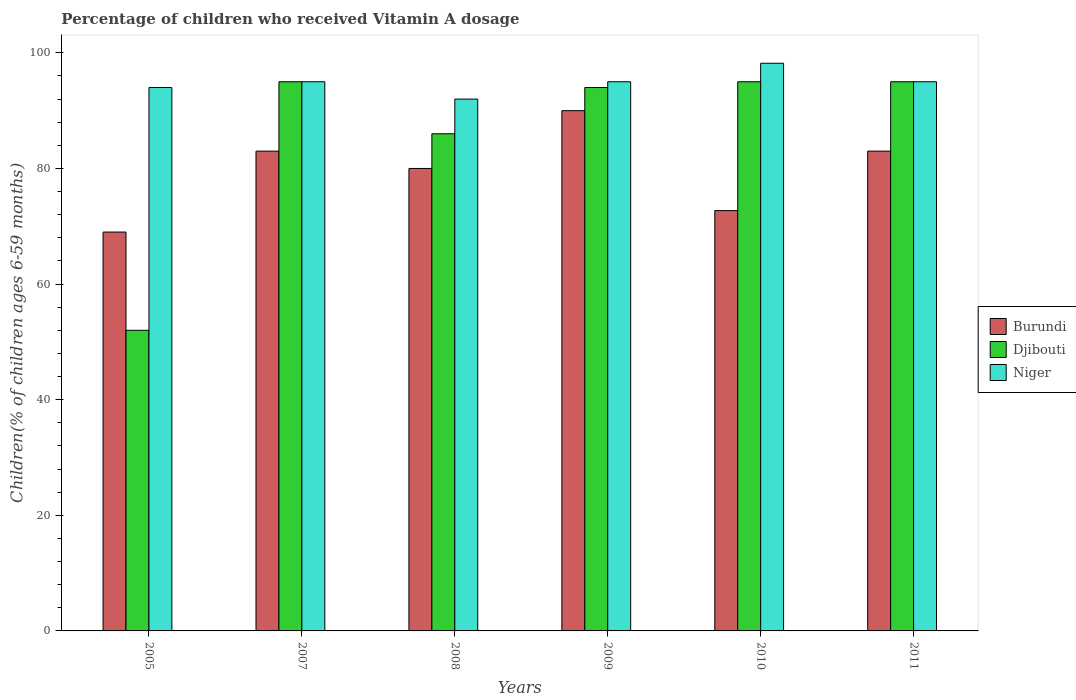How many groups of bars are there?
Keep it short and to the point. 6. How many bars are there on the 1st tick from the right?
Ensure brevity in your answer.  3. What is the label of the 3rd group of bars from the left?
Your answer should be very brief. 2008. In how many cases, is the number of bars for a given year not equal to the number of legend labels?
Keep it short and to the point. 0. What is the percentage of children who received Vitamin A dosage in Niger in 2008?
Offer a terse response. 92. Across all years, what is the maximum percentage of children who received Vitamin A dosage in Djibouti?
Your response must be concise. 95. Across all years, what is the minimum percentage of children who received Vitamin A dosage in Burundi?
Provide a short and direct response. 69. In which year was the percentage of children who received Vitamin A dosage in Niger maximum?
Your answer should be very brief. 2010. In which year was the percentage of children who received Vitamin A dosage in Niger minimum?
Keep it short and to the point. 2008. What is the total percentage of children who received Vitamin A dosage in Niger in the graph?
Give a very brief answer. 569.2. What is the difference between the percentage of children who received Vitamin A dosage in Niger in 2008 and that in 2010?
Provide a succinct answer. -6.2. What is the difference between the percentage of children who received Vitamin A dosage in Burundi in 2010 and the percentage of children who received Vitamin A dosage in Niger in 2009?
Ensure brevity in your answer.  -22.29. What is the average percentage of children who received Vitamin A dosage in Niger per year?
Make the answer very short. 94.87. In the year 2010, what is the difference between the percentage of children who received Vitamin A dosage in Niger and percentage of children who received Vitamin A dosage in Burundi?
Keep it short and to the point. 25.49. What is the ratio of the percentage of children who received Vitamin A dosage in Burundi in 2009 to that in 2011?
Give a very brief answer. 1.08. Is the difference between the percentage of children who received Vitamin A dosage in Niger in 2005 and 2007 greater than the difference between the percentage of children who received Vitamin A dosage in Burundi in 2005 and 2007?
Keep it short and to the point. Yes. What is the difference between the highest and the second highest percentage of children who received Vitamin A dosage in Niger?
Make the answer very short. 3.2. In how many years, is the percentage of children who received Vitamin A dosage in Niger greater than the average percentage of children who received Vitamin A dosage in Niger taken over all years?
Keep it short and to the point. 4. Is the sum of the percentage of children who received Vitamin A dosage in Burundi in 2008 and 2010 greater than the maximum percentage of children who received Vitamin A dosage in Niger across all years?
Offer a very short reply. Yes. What does the 3rd bar from the left in 2005 represents?
Ensure brevity in your answer.  Niger. What does the 3rd bar from the right in 2009 represents?
Your answer should be compact. Burundi. How many bars are there?
Your answer should be compact. 18. Are all the bars in the graph horizontal?
Provide a succinct answer. No. What is the difference between two consecutive major ticks on the Y-axis?
Give a very brief answer. 20. Does the graph contain grids?
Offer a terse response. No. How many legend labels are there?
Keep it short and to the point. 3. What is the title of the graph?
Your answer should be very brief. Percentage of children who received Vitamin A dosage. Does "Yemen, Rep." appear as one of the legend labels in the graph?
Your answer should be compact. No. What is the label or title of the Y-axis?
Make the answer very short. Children(% of children ages 6-59 months). What is the Children(% of children ages 6-59 months) in Djibouti in 2005?
Keep it short and to the point. 52. What is the Children(% of children ages 6-59 months) in Niger in 2005?
Make the answer very short. 94. What is the Children(% of children ages 6-59 months) in Djibouti in 2007?
Provide a succinct answer. 95. What is the Children(% of children ages 6-59 months) in Burundi in 2008?
Your answer should be very brief. 80. What is the Children(% of children ages 6-59 months) of Djibouti in 2008?
Give a very brief answer. 86. What is the Children(% of children ages 6-59 months) of Niger in 2008?
Your response must be concise. 92. What is the Children(% of children ages 6-59 months) in Djibouti in 2009?
Your answer should be very brief. 94. What is the Children(% of children ages 6-59 months) of Niger in 2009?
Offer a terse response. 95. What is the Children(% of children ages 6-59 months) of Burundi in 2010?
Offer a terse response. 72.71. What is the Children(% of children ages 6-59 months) in Djibouti in 2010?
Keep it short and to the point. 95. What is the Children(% of children ages 6-59 months) of Niger in 2010?
Your response must be concise. 98.2. What is the Children(% of children ages 6-59 months) of Djibouti in 2011?
Offer a terse response. 95. What is the Children(% of children ages 6-59 months) in Niger in 2011?
Make the answer very short. 95. Across all years, what is the maximum Children(% of children ages 6-59 months) in Niger?
Offer a very short reply. 98.2. Across all years, what is the minimum Children(% of children ages 6-59 months) in Burundi?
Make the answer very short. 69. Across all years, what is the minimum Children(% of children ages 6-59 months) in Djibouti?
Offer a very short reply. 52. Across all years, what is the minimum Children(% of children ages 6-59 months) in Niger?
Your answer should be very brief. 92. What is the total Children(% of children ages 6-59 months) of Burundi in the graph?
Make the answer very short. 477.71. What is the total Children(% of children ages 6-59 months) in Djibouti in the graph?
Your answer should be compact. 517. What is the total Children(% of children ages 6-59 months) in Niger in the graph?
Provide a short and direct response. 569.2. What is the difference between the Children(% of children ages 6-59 months) of Djibouti in 2005 and that in 2007?
Offer a terse response. -43. What is the difference between the Children(% of children ages 6-59 months) of Niger in 2005 and that in 2007?
Provide a succinct answer. -1. What is the difference between the Children(% of children ages 6-59 months) in Burundi in 2005 and that in 2008?
Your answer should be very brief. -11. What is the difference between the Children(% of children ages 6-59 months) in Djibouti in 2005 and that in 2008?
Provide a short and direct response. -34. What is the difference between the Children(% of children ages 6-59 months) in Niger in 2005 and that in 2008?
Give a very brief answer. 2. What is the difference between the Children(% of children ages 6-59 months) in Burundi in 2005 and that in 2009?
Provide a succinct answer. -21. What is the difference between the Children(% of children ages 6-59 months) of Djibouti in 2005 and that in 2009?
Offer a terse response. -42. What is the difference between the Children(% of children ages 6-59 months) in Burundi in 2005 and that in 2010?
Provide a succinct answer. -3.71. What is the difference between the Children(% of children ages 6-59 months) in Djibouti in 2005 and that in 2010?
Offer a terse response. -43. What is the difference between the Children(% of children ages 6-59 months) in Niger in 2005 and that in 2010?
Ensure brevity in your answer.  -4.2. What is the difference between the Children(% of children ages 6-59 months) of Burundi in 2005 and that in 2011?
Your answer should be compact. -14. What is the difference between the Children(% of children ages 6-59 months) in Djibouti in 2005 and that in 2011?
Make the answer very short. -43. What is the difference between the Children(% of children ages 6-59 months) of Niger in 2005 and that in 2011?
Provide a short and direct response. -1. What is the difference between the Children(% of children ages 6-59 months) in Burundi in 2007 and that in 2008?
Ensure brevity in your answer.  3. What is the difference between the Children(% of children ages 6-59 months) in Djibouti in 2007 and that in 2008?
Your response must be concise. 9. What is the difference between the Children(% of children ages 6-59 months) in Niger in 2007 and that in 2008?
Offer a terse response. 3. What is the difference between the Children(% of children ages 6-59 months) of Burundi in 2007 and that in 2009?
Your answer should be compact. -7. What is the difference between the Children(% of children ages 6-59 months) in Djibouti in 2007 and that in 2009?
Ensure brevity in your answer.  1. What is the difference between the Children(% of children ages 6-59 months) of Niger in 2007 and that in 2009?
Give a very brief answer. 0. What is the difference between the Children(% of children ages 6-59 months) of Burundi in 2007 and that in 2010?
Your response must be concise. 10.29. What is the difference between the Children(% of children ages 6-59 months) of Djibouti in 2007 and that in 2010?
Offer a very short reply. 0. What is the difference between the Children(% of children ages 6-59 months) of Niger in 2007 and that in 2010?
Give a very brief answer. -3.2. What is the difference between the Children(% of children ages 6-59 months) of Burundi in 2007 and that in 2011?
Offer a terse response. 0. What is the difference between the Children(% of children ages 6-59 months) in Burundi in 2008 and that in 2009?
Ensure brevity in your answer.  -10. What is the difference between the Children(% of children ages 6-59 months) in Djibouti in 2008 and that in 2009?
Keep it short and to the point. -8. What is the difference between the Children(% of children ages 6-59 months) in Niger in 2008 and that in 2009?
Offer a terse response. -3. What is the difference between the Children(% of children ages 6-59 months) of Burundi in 2008 and that in 2010?
Give a very brief answer. 7.29. What is the difference between the Children(% of children ages 6-59 months) of Djibouti in 2008 and that in 2010?
Make the answer very short. -9. What is the difference between the Children(% of children ages 6-59 months) in Niger in 2008 and that in 2010?
Give a very brief answer. -6.2. What is the difference between the Children(% of children ages 6-59 months) of Burundi in 2008 and that in 2011?
Keep it short and to the point. -3. What is the difference between the Children(% of children ages 6-59 months) of Djibouti in 2008 and that in 2011?
Your answer should be very brief. -9. What is the difference between the Children(% of children ages 6-59 months) of Niger in 2008 and that in 2011?
Your response must be concise. -3. What is the difference between the Children(% of children ages 6-59 months) in Burundi in 2009 and that in 2010?
Provide a succinct answer. 17.29. What is the difference between the Children(% of children ages 6-59 months) in Djibouti in 2009 and that in 2010?
Provide a succinct answer. -1. What is the difference between the Children(% of children ages 6-59 months) of Niger in 2009 and that in 2010?
Provide a short and direct response. -3.2. What is the difference between the Children(% of children ages 6-59 months) in Burundi in 2010 and that in 2011?
Give a very brief answer. -10.29. What is the difference between the Children(% of children ages 6-59 months) in Djibouti in 2010 and that in 2011?
Your response must be concise. 0. What is the difference between the Children(% of children ages 6-59 months) of Niger in 2010 and that in 2011?
Make the answer very short. 3.2. What is the difference between the Children(% of children ages 6-59 months) of Burundi in 2005 and the Children(% of children ages 6-59 months) of Niger in 2007?
Make the answer very short. -26. What is the difference between the Children(% of children ages 6-59 months) in Djibouti in 2005 and the Children(% of children ages 6-59 months) in Niger in 2007?
Your answer should be very brief. -43. What is the difference between the Children(% of children ages 6-59 months) of Burundi in 2005 and the Children(% of children ages 6-59 months) of Djibouti in 2009?
Make the answer very short. -25. What is the difference between the Children(% of children ages 6-59 months) of Djibouti in 2005 and the Children(% of children ages 6-59 months) of Niger in 2009?
Your response must be concise. -43. What is the difference between the Children(% of children ages 6-59 months) of Burundi in 2005 and the Children(% of children ages 6-59 months) of Djibouti in 2010?
Offer a terse response. -26. What is the difference between the Children(% of children ages 6-59 months) in Burundi in 2005 and the Children(% of children ages 6-59 months) in Niger in 2010?
Make the answer very short. -29.2. What is the difference between the Children(% of children ages 6-59 months) in Djibouti in 2005 and the Children(% of children ages 6-59 months) in Niger in 2010?
Offer a terse response. -46.2. What is the difference between the Children(% of children ages 6-59 months) of Burundi in 2005 and the Children(% of children ages 6-59 months) of Niger in 2011?
Your answer should be very brief. -26. What is the difference between the Children(% of children ages 6-59 months) in Djibouti in 2005 and the Children(% of children ages 6-59 months) in Niger in 2011?
Your answer should be very brief. -43. What is the difference between the Children(% of children ages 6-59 months) of Burundi in 2007 and the Children(% of children ages 6-59 months) of Djibouti in 2008?
Your response must be concise. -3. What is the difference between the Children(% of children ages 6-59 months) in Djibouti in 2007 and the Children(% of children ages 6-59 months) in Niger in 2008?
Offer a terse response. 3. What is the difference between the Children(% of children ages 6-59 months) in Burundi in 2007 and the Children(% of children ages 6-59 months) in Niger in 2009?
Offer a very short reply. -12. What is the difference between the Children(% of children ages 6-59 months) in Burundi in 2007 and the Children(% of children ages 6-59 months) in Djibouti in 2010?
Your answer should be compact. -12. What is the difference between the Children(% of children ages 6-59 months) in Burundi in 2007 and the Children(% of children ages 6-59 months) in Niger in 2010?
Offer a terse response. -15.2. What is the difference between the Children(% of children ages 6-59 months) of Djibouti in 2007 and the Children(% of children ages 6-59 months) of Niger in 2010?
Provide a short and direct response. -3.2. What is the difference between the Children(% of children ages 6-59 months) of Burundi in 2007 and the Children(% of children ages 6-59 months) of Djibouti in 2011?
Give a very brief answer. -12. What is the difference between the Children(% of children ages 6-59 months) in Burundi in 2007 and the Children(% of children ages 6-59 months) in Niger in 2011?
Offer a very short reply. -12. What is the difference between the Children(% of children ages 6-59 months) of Burundi in 2008 and the Children(% of children ages 6-59 months) of Djibouti in 2009?
Give a very brief answer. -14. What is the difference between the Children(% of children ages 6-59 months) of Burundi in 2008 and the Children(% of children ages 6-59 months) of Niger in 2009?
Provide a short and direct response. -15. What is the difference between the Children(% of children ages 6-59 months) in Djibouti in 2008 and the Children(% of children ages 6-59 months) in Niger in 2009?
Provide a short and direct response. -9. What is the difference between the Children(% of children ages 6-59 months) in Burundi in 2008 and the Children(% of children ages 6-59 months) in Niger in 2010?
Your answer should be compact. -18.2. What is the difference between the Children(% of children ages 6-59 months) in Djibouti in 2008 and the Children(% of children ages 6-59 months) in Niger in 2010?
Make the answer very short. -12.2. What is the difference between the Children(% of children ages 6-59 months) in Burundi in 2008 and the Children(% of children ages 6-59 months) in Djibouti in 2011?
Your answer should be compact. -15. What is the difference between the Children(% of children ages 6-59 months) in Djibouti in 2008 and the Children(% of children ages 6-59 months) in Niger in 2011?
Offer a terse response. -9. What is the difference between the Children(% of children ages 6-59 months) of Burundi in 2009 and the Children(% of children ages 6-59 months) of Djibouti in 2010?
Your answer should be compact. -5. What is the difference between the Children(% of children ages 6-59 months) in Burundi in 2009 and the Children(% of children ages 6-59 months) in Niger in 2010?
Provide a succinct answer. -8.2. What is the difference between the Children(% of children ages 6-59 months) of Djibouti in 2009 and the Children(% of children ages 6-59 months) of Niger in 2010?
Offer a terse response. -4.2. What is the difference between the Children(% of children ages 6-59 months) in Burundi in 2009 and the Children(% of children ages 6-59 months) in Djibouti in 2011?
Offer a terse response. -5. What is the difference between the Children(% of children ages 6-59 months) of Burundi in 2009 and the Children(% of children ages 6-59 months) of Niger in 2011?
Make the answer very short. -5. What is the difference between the Children(% of children ages 6-59 months) in Burundi in 2010 and the Children(% of children ages 6-59 months) in Djibouti in 2011?
Offer a very short reply. -22.29. What is the difference between the Children(% of children ages 6-59 months) in Burundi in 2010 and the Children(% of children ages 6-59 months) in Niger in 2011?
Provide a succinct answer. -22.29. What is the difference between the Children(% of children ages 6-59 months) of Djibouti in 2010 and the Children(% of children ages 6-59 months) of Niger in 2011?
Offer a very short reply. 0. What is the average Children(% of children ages 6-59 months) in Burundi per year?
Ensure brevity in your answer.  79.62. What is the average Children(% of children ages 6-59 months) of Djibouti per year?
Your answer should be compact. 86.17. What is the average Children(% of children ages 6-59 months) in Niger per year?
Give a very brief answer. 94.87. In the year 2005, what is the difference between the Children(% of children ages 6-59 months) of Djibouti and Children(% of children ages 6-59 months) of Niger?
Provide a short and direct response. -42. In the year 2007, what is the difference between the Children(% of children ages 6-59 months) in Burundi and Children(% of children ages 6-59 months) in Djibouti?
Offer a terse response. -12. In the year 2010, what is the difference between the Children(% of children ages 6-59 months) in Burundi and Children(% of children ages 6-59 months) in Djibouti?
Ensure brevity in your answer.  -22.29. In the year 2010, what is the difference between the Children(% of children ages 6-59 months) of Burundi and Children(% of children ages 6-59 months) of Niger?
Provide a succinct answer. -25.49. In the year 2010, what is the difference between the Children(% of children ages 6-59 months) in Djibouti and Children(% of children ages 6-59 months) in Niger?
Provide a succinct answer. -3.2. In the year 2011, what is the difference between the Children(% of children ages 6-59 months) in Burundi and Children(% of children ages 6-59 months) in Djibouti?
Give a very brief answer. -12. In the year 2011, what is the difference between the Children(% of children ages 6-59 months) in Burundi and Children(% of children ages 6-59 months) in Niger?
Provide a short and direct response. -12. In the year 2011, what is the difference between the Children(% of children ages 6-59 months) of Djibouti and Children(% of children ages 6-59 months) of Niger?
Your answer should be very brief. 0. What is the ratio of the Children(% of children ages 6-59 months) of Burundi in 2005 to that in 2007?
Give a very brief answer. 0.83. What is the ratio of the Children(% of children ages 6-59 months) of Djibouti in 2005 to that in 2007?
Offer a terse response. 0.55. What is the ratio of the Children(% of children ages 6-59 months) of Niger in 2005 to that in 2007?
Your answer should be very brief. 0.99. What is the ratio of the Children(% of children ages 6-59 months) of Burundi in 2005 to that in 2008?
Keep it short and to the point. 0.86. What is the ratio of the Children(% of children ages 6-59 months) in Djibouti in 2005 to that in 2008?
Offer a terse response. 0.6. What is the ratio of the Children(% of children ages 6-59 months) of Niger in 2005 to that in 2008?
Your response must be concise. 1.02. What is the ratio of the Children(% of children ages 6-59 months) of Burundi in 2005 to that in 2009?
Offer a very short reply. 0.77. What is the ratio of the Children(% of children ages 6-59 months) of Djibouti in 2005 to that in 2009?
Keep it short and to the point. 0.55. What is the ratio of the Children(% of children ages 6-59 months) of Niger in 2005 to that in 2009?
Offer a terse response. 0.99. What is the ratio of the Children(% of children ages 6-59 months) in Burundi in 2005 to that in 2010?
Your answer should be compact. 0.95. What is the ratio of the Children(% of children ages 6-59 months) in Djibouti in 2005 to that in 2010?
Keep it short and to the point. 0.55. What is the ratio of the Children(% of children ages 6-59 months) of Niger in 2005 to that in 2010?
Your answer should be very brief. 0.96. What is the ratio of the Children(% of children ages 6-59 months) in Burundi in 2005 to that in 2011?
Give a very brief answer. 0.83. What is the ratio of the Children(% of children ages 6-59 months) in Djibouti in 2005 to that in 2011?
Your answer should be compact. 0.55. What is the ratio of the Children(% of children ages 6-59 months) of Niger in 2005 to that in 2011?
Your answer should be very brief. 0.99. What is the ratio of the Children(% of children ages 6-59 months) of Burundi in 2007 to that in 2008?
Make the answer very short. 1.04. What is the ratio of the Children(% of children ages 6-59 months) of Djibouti in 2007 to that in 2008?
Provide a succinct answer. 1.1. What is the ratio of the Children(% of children ages 6-59 months) in Niger in 2007 to that in 2008?
Your response must be concise. 1.03. What is the ratio of the Children(% of children ages 6-59 months) of Burundi in 2007 to that in 2009?
Ensure brevity in your answer.  0.92. What is the ratio of the Children(% of children ages 6-59 months) in Djibouti in 2007 to that in 2009?
Ensure brevity in your answer.  1.01. What is the ratio of the Children(% of children ages 6-59 months) in Niger in 2007 to that in 2009?
Your answer should be compact. 1. What is the ratio of the Children(% of children ages 6-59 months) of Burundi in 2007 to that in 2010?
Give a very brief answer. 1.14. What is the ratio of the Children(% of children ages 6-59 months) in Niger in 2007 to that in 2010?
Your response must be concise. 0.97. What is the ratio of the Children(% of children ages 6-59 months) of Niger in 2007 to that in 2011?
Offer a very short reply. 1. What is the ratio of the Children(% of children ages 6-59 months) in Djibouti in 2008 to that in 2009?
Offer a terse response. 0.91. What is the ratio of the Children(% of children ages 6-59 months) of Niger in 2008 to that in 2009?
Provide a succinct answer. 0.97. What is the ratio of the Children(% of children ages 6-59 months) of Burundi in 2008 to that in 2010?
Your answer should be very brief. 1.1. What is the ratio of the Children(% of children ages 6-59 months) of Djibouti in 2008 to that in 2010?
Give a very brief answer. 0.91. What is the ratio of the Children(% of children ages 6-59 months) of Niger in 2008 to that in 2010?
Provide a short and direct response. 0.94. What is the ratio of the Children(% of children ages 6-59 months) in Burundi in 2008 to that in 2011?
Make the answer very short. 0.96. What is the ratio of the Children(% of children ages 6-59 months) in Djibouti in 2008 to that in 2011?
Keep it short and to the point. 0.91. What is the ratio of the Children(% of children ages 6-59 months) in Niger in 2008 to that in 2011?
Offer a very short reply. 0.97. What is the ratio of the Children(% of children ages 6-59 months) of Burundi in 2009 to that in 2010?
Provide a short and direct response. 1.24. What is the ratio of the Children(% of children ages 6-59 months) in Djibouti in 2009 to that in 2010?
Your response must be concise. 0.99. What is the ratio of the Children(% of children ages 6-59 months) of Niger in 2009 to that in 2010?
Provide a succinct answer. 0.97. What is the ratio of the Children(% of children ages 6-59 months) of Burundi in 2009 to that in 2011?
Make the answer very short. 1.08. What is the ratio of the Children(% of children ages 6-59 months) of Niger in 2009 to that in 2011?
Make the answer very short. 1. What is the ratio of the Children(% of children ages 6-59 months) of Burundi in 2010 to that in 2011?
Keep it short and to the point. 0.88. What is the ratio of the Children(% of children ages 6-59 months) in Djibouti in 2010 to that in 2011?
Ensure brevity in your answer.  1. What is the ratio of the Children(% of children ages 6-59 months) in Niger in 2010 to that in 2011?
Offer a terse response. 1.03. What is the difference between the highest and the second highest Children(% of children ages 6-59 months) of Burundi?
Ensure brevity in your answer.  7. What is the difference between the highest and the second highest Children(% of children ages 6-59 months) in Djibouti?
Your response must be concise. 0. What is the difference between the highest and the second highest Children(% of children ages 6-59 months) in Niger?
Offer a very short reply. 3.2. What is the difference between the highest and the lowest Children(% of children ages 6-59 months) in Djibouti?
Provide a succinct answer. 43. What is the difference between the highest and the lowest Children(% of children ages 6-59 months) of Niger?
Keep it short and to the point. 6.2. 